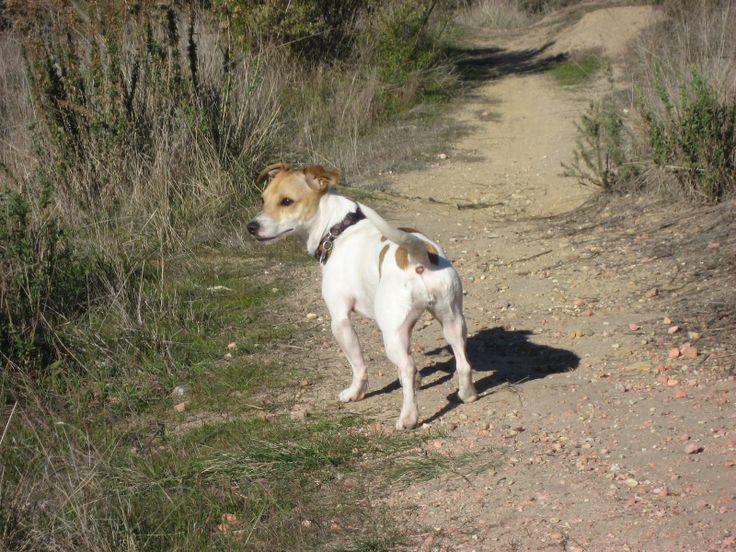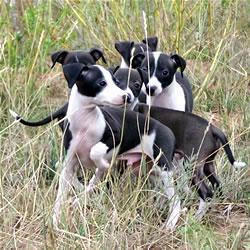The first image is the image on the left, the second image is the image on the right. Evaluate the accuracy of this statement regarding the images: "One of the paired images shows multiple black and white dogs.". Is it true? Answer yes or no. Yes. 